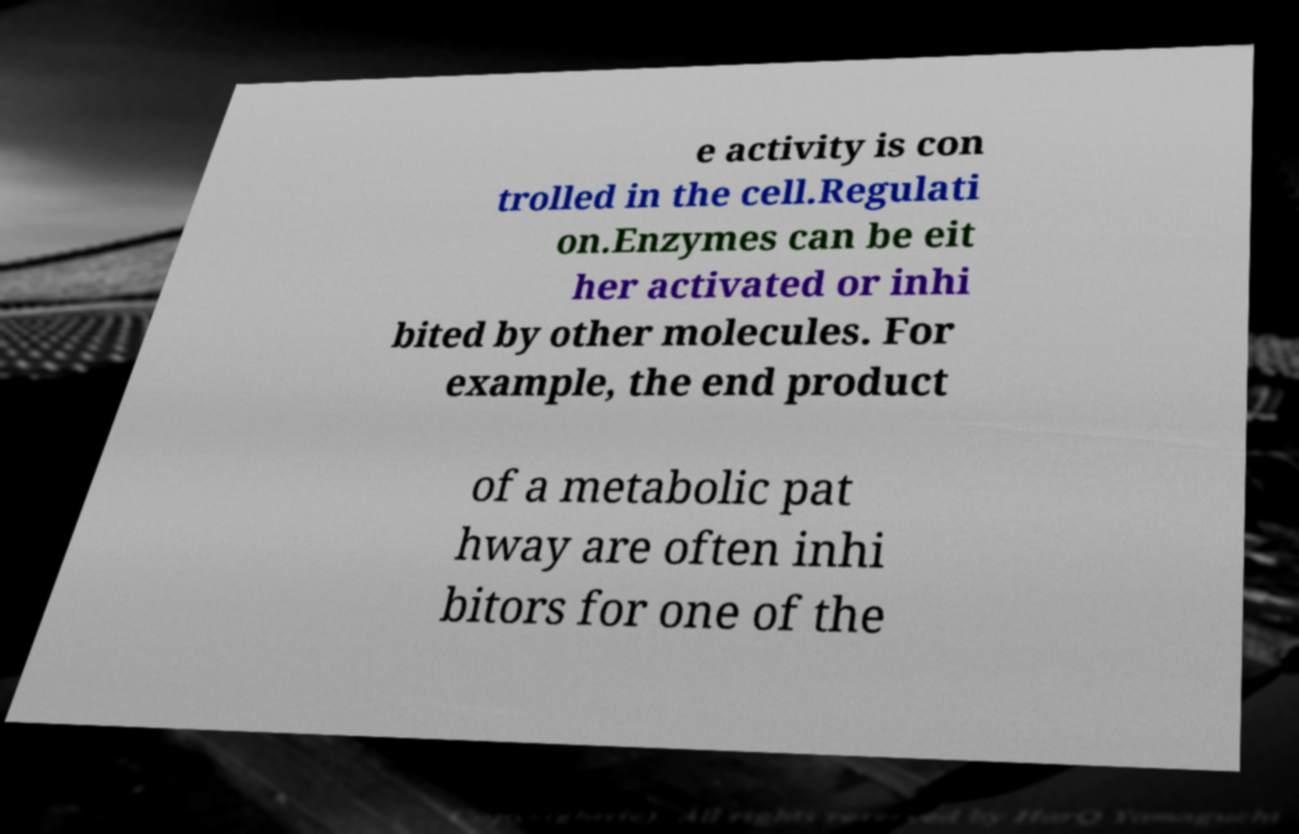Can you accurately transcribe the text from the provided image for me? e activity is con trolled in the cell.Regulati on.Enzymes can be eit her activated or inhi bited by other molecules. For example, the end product of a metabolic pat hway are often inhi bitors for one of the 